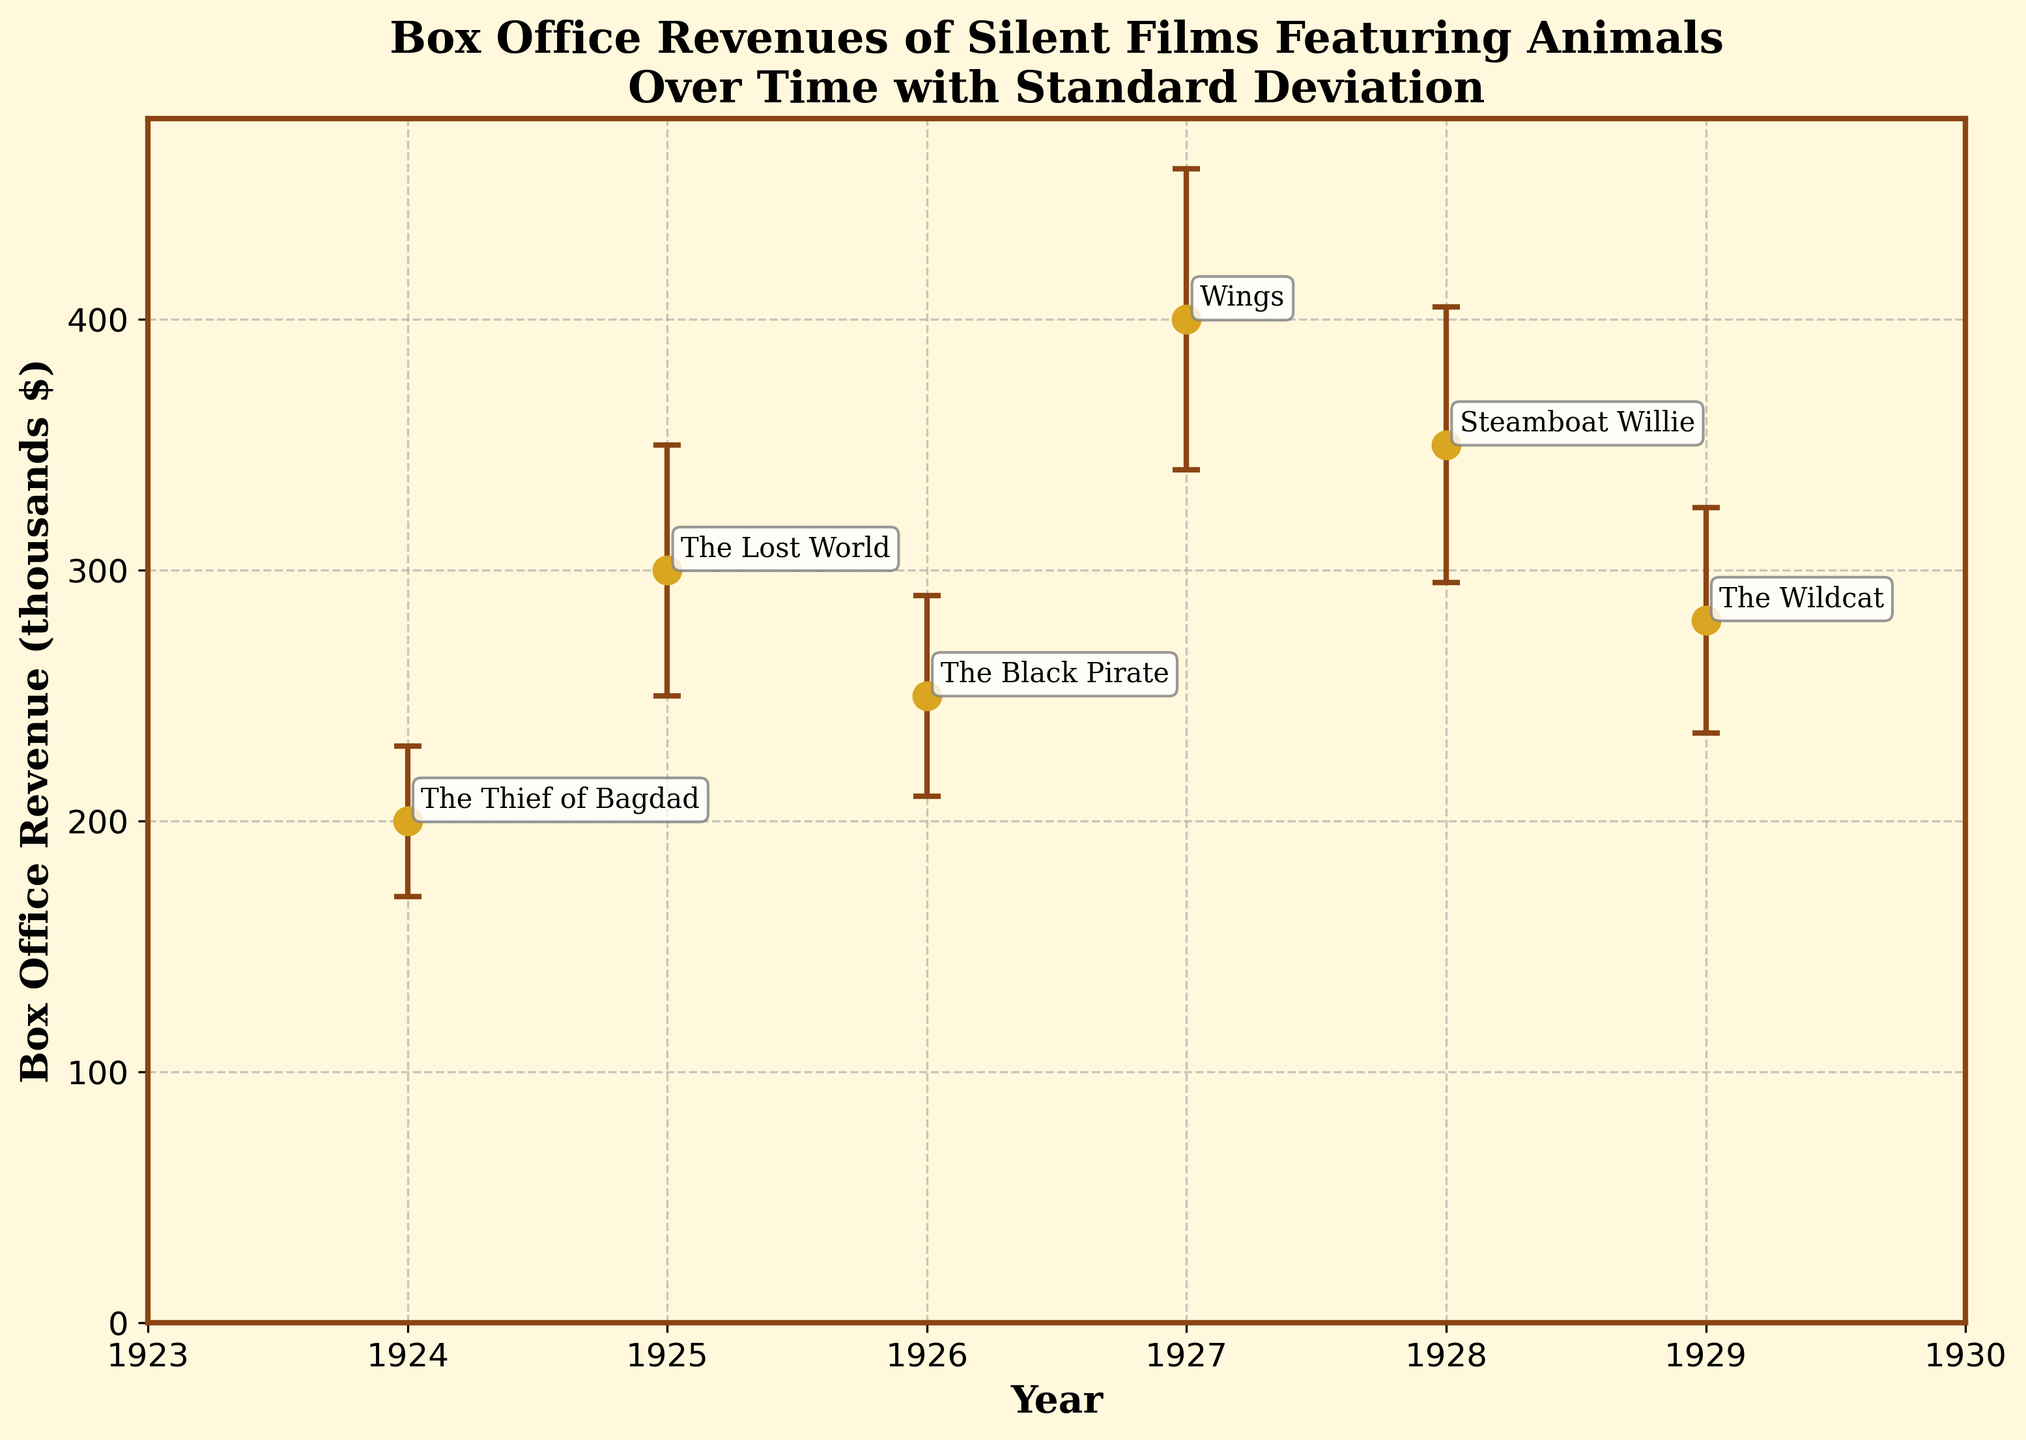What is the title of the plot? The title is prominently displayed at the top and provides an overview of the data being presented.
Answer: Box Office Revenues of Silent Films Featuring Animals Over Time with Standard Deviation What year did "Wings" achieve its box office revenue, and what was that amount? Locate the annotation for "Wings" on the plot to identify its corresponding year and revenue amount.
Answer: 1927, 400 (in thousands $) Which film has the highest box office revenue, and what is the value? By observing the vertical axis and identifying the highest data point, we can determine the film and its revenue.
Answer: Wings, 400 (in thousands $) What is the standard deviation for "Steamboat Willie"? Check the error bars associated with "Steamboat Willie" to find its standard deviation, which is given in the data.
Answer: 55 (in thousands $) Which year saw the lowest box office revenue among the films listed, and what was the amount? Identify the lowest data point on the plot and note its corresponding year and revenue value.
Answer: 1924, 200 (in thousands $) What is the average box office revenue of the films? Sum all box office revenues and divide by the total number of films to calculate the average. (200+300+250+400+350+280) / 6
Answer: 296.67 (in thousands $) What is the difference in box office revenue between "The Thief of Bagdad" and "The Lost World"? Subtract the revenue of "The Thief of Bagdad" from that of "The Lost World" for the difference. 300 - 200
Answer: 100 (in thousands $) How many films have a box office revenue of more than 300 (in thousands $)? Count the number of data points above the 300 thousand dollars mark on the plot.
Answer: 3 films Which years have films that experienced the greatest and smallest uncertainty in box office revenue? To determine uncertainty, look at the length of the error bars (standard deviation). The longest indicates greatest uncertainty, and the shortest the smallest uncertainty.
Answer: 1927 (greatest), 1924 (smallest) What is the range of the box office revenue for the films? Subtract the lowest revenue from the highest revenue to find the range. 400 - 200
Answer: 200 (in thousands $) 